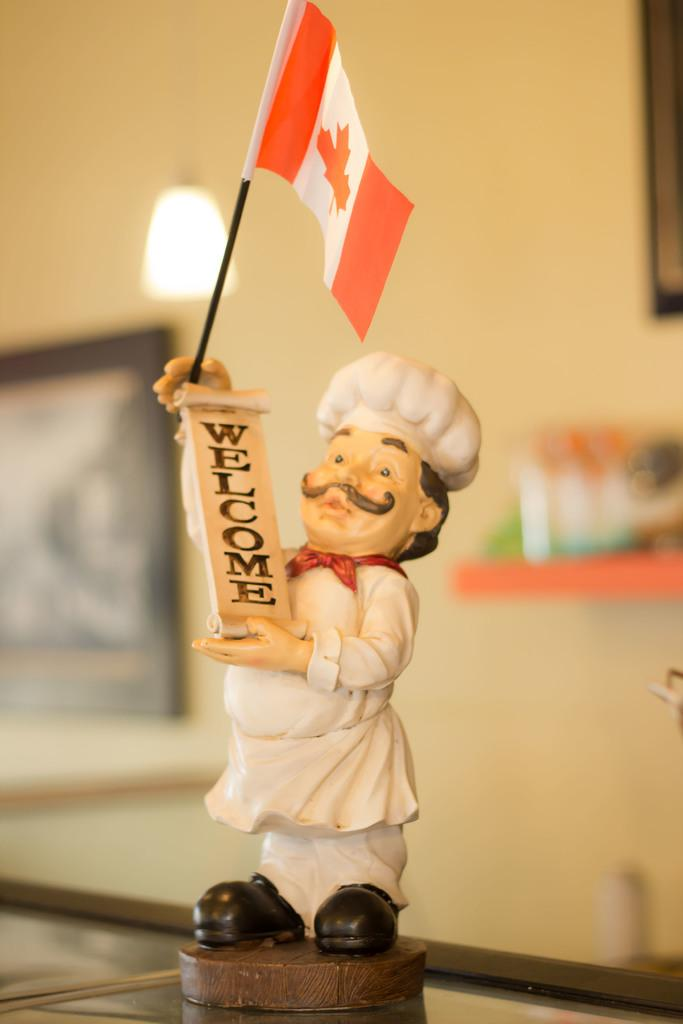What is located on the floor in the foreground of the image? There is a statue on the floor in the foreground. What else can be seen in the foreground of the image? There is a board and a flag in the foreground. What is visible in the background of the image? There is a wall, a light, and wall paintings in the background. Can you describe the setting where the image might have been taken? The image may have been taken in a hall, based on the presence of a wall and the size of the space. How far away is the deer from the statue in the image? There is no deer present in the image, so it is not possible to determine the distance between the statue and a deer. What type of cup can be seen in the image? There is no cup present in the image. 